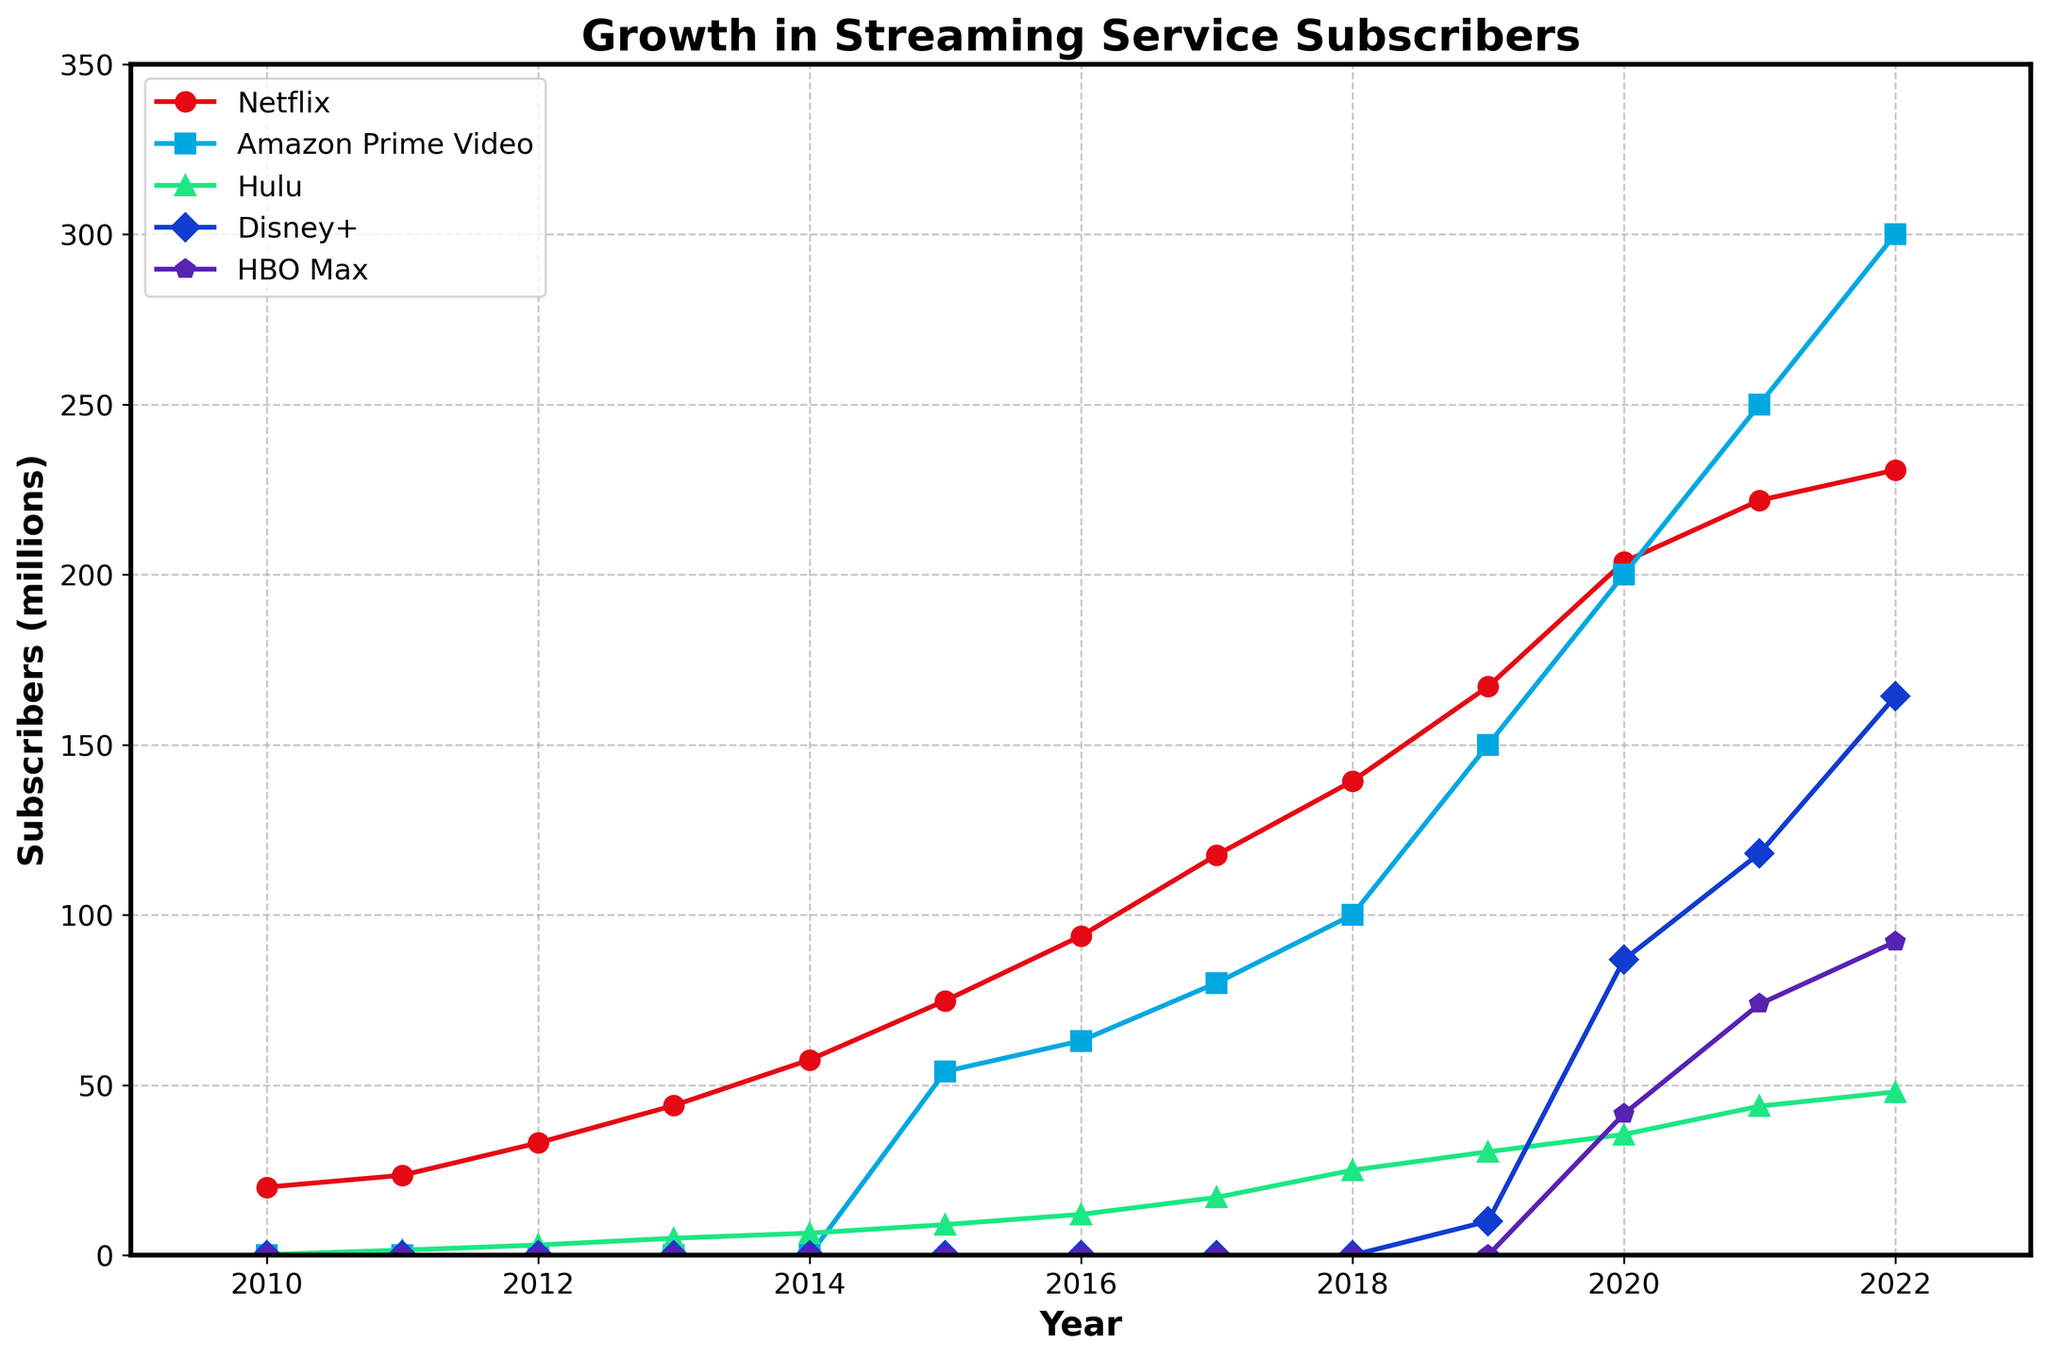Which platform had the most subscribers in 2022? In the figure, the line corresponding to Netflix reaches the highest value in 2022, indicating that Netflix had the most subscribers in that year.
Answer: Netflix How much did Hulu's subscribers increase from 2010 to 2022? In 2010, Hulu had 0.2 million subscribers, and in 2022, it had 48 million subscribers. The increase can be calculated as 48 - 0.2 = 47.8 million.
Answer: 47.8 million Which two platforms have similar subscriber numbers in 2021? Looking at the 2021 data points, HBO Max and Disney+ have similar subscriber numbers with their lines near each other (HBO Max: 73.8 million, Disney+: 118.1 million).
Answer: HBO Max and Disney+ Between 2019 and 2020, which platform had the largest growth in subscribers? By checking the difference in subscriber numbers between 2019 and 2020, Disney+ had the largest growth, going from 10 million to 86.8 million, an increase of 76.8 million.
Answer: Disney+ What color represents Amazon Prime Video in the figure? The blue color line represents Amazon Prime Video in the figure, as indicated by the legend.
Answer: Blue Which platform had zero subscribers until 2015? Amazon Prime Video had zero subscribers until 2015, as its line starts at the 2015 mark in the figure.
Answer: Amazon Prime Video What is the average number of subscribers for Netflix from 2010 to 2022? Summing the numbers for Netflix (20, 23.5, 33, 44, 57.4, 74.8, 93.8, 117.6, 139.3, 167.1, 203.7, 221.8, 230.7) gives 1427.7. Dividing by 13 gives an average of approximately 109.8 million.
Answer: 109.8 million Which platform experienced the first significant growth after 2018? Disney+ saw its first significant growth in subscribers after 2018, with an increase from zero to 10 million in 2019.
Answer: Disney+ What was the total number of subscribers for all platforms combined in 2020? Summing the 2020 subscriber numbers: Netflix (203.7), Amazon Prime Video (200), Hulu (35.5), Disney+ (86.8), HBO Max (41.5) gives 567.5 million.
Answer: 567.5 million 